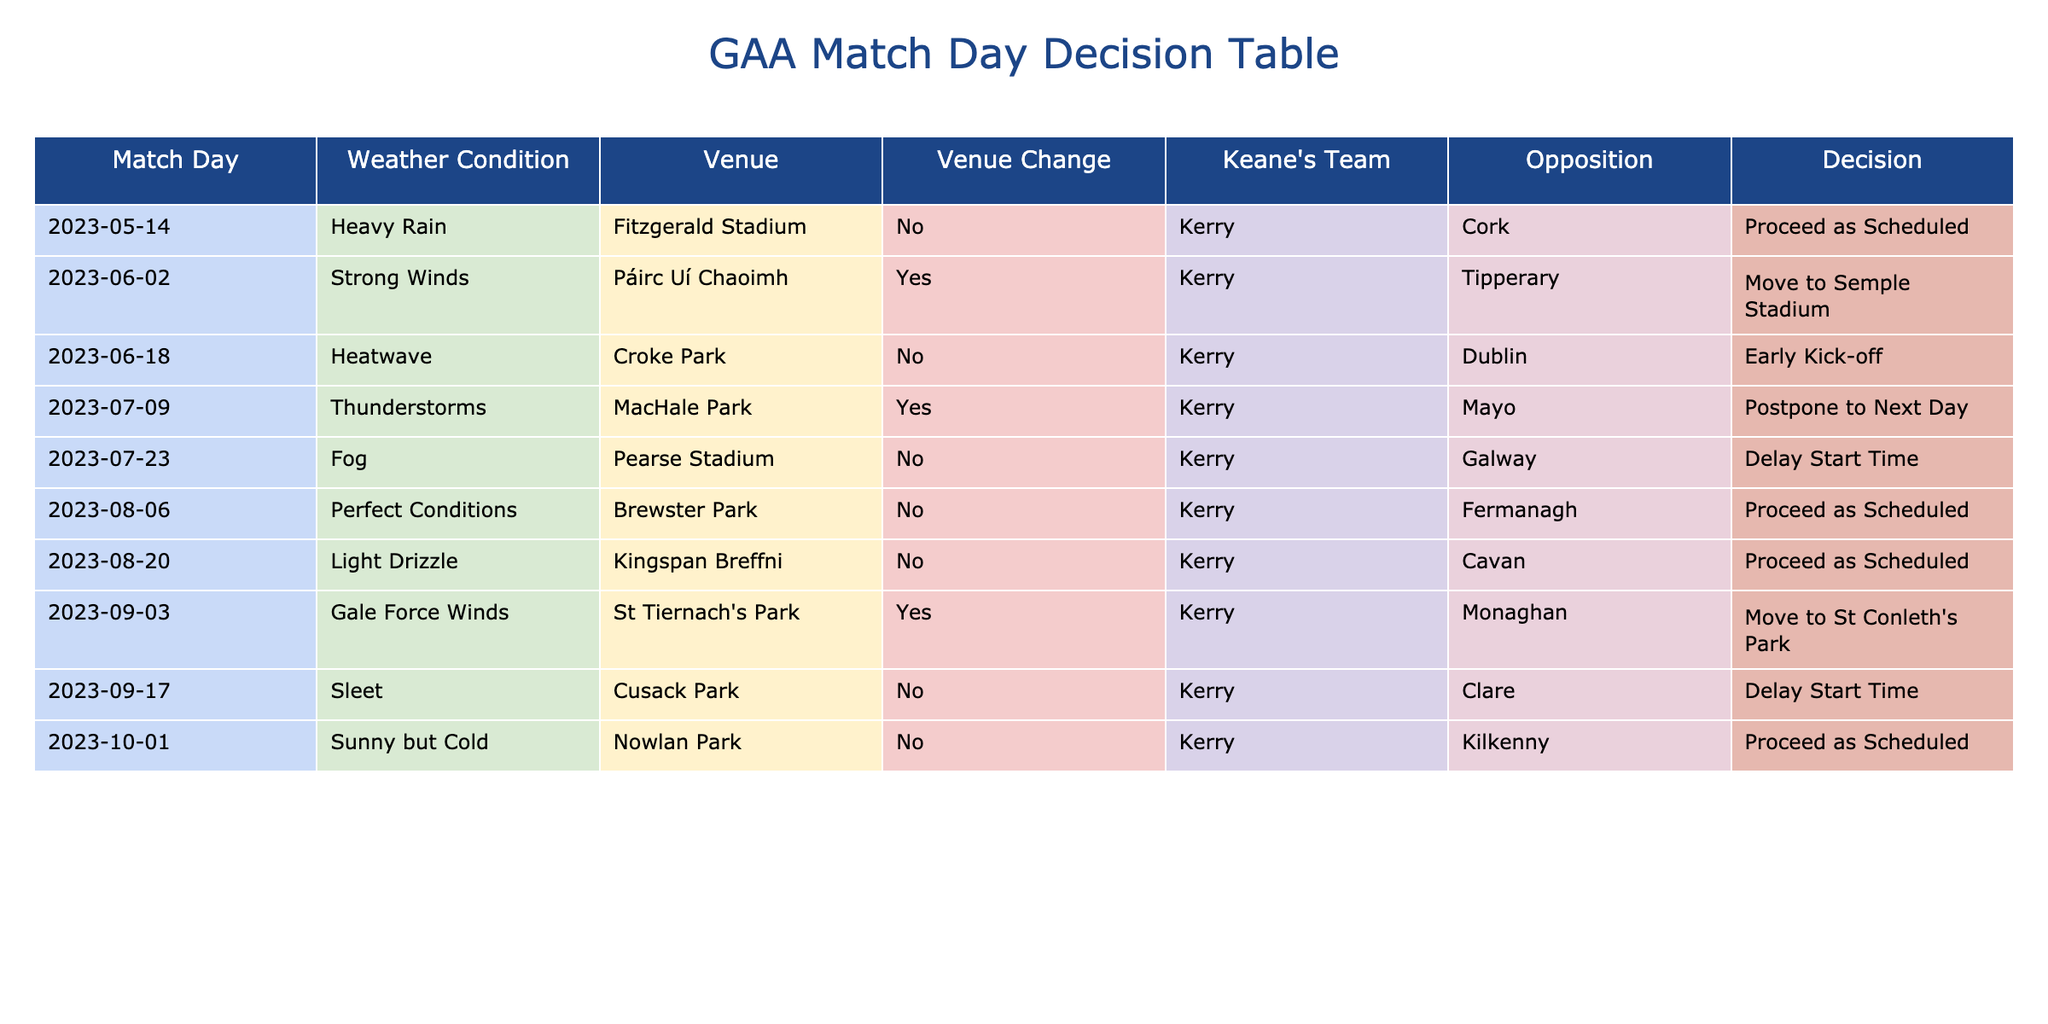What was the weather condition during the match on June 2, 2023? According to the table, on June 2, 2023, the weather condition was "Strong Winds."
Answer: Strong Winds Which match was postponed to the next day? The match scheduled for July 9, 2023, was postponed due to "Thunderstorms."
Answer: July 9, 2023 How many matches were played under perfect conditions? There was one match listed with "Perfect Conditions," which took place on August 6, 2023.
Answer: 1 Was there a venue change for the match against Tipperary? Yes, for the match against Tipperary on June 2, 2023, the venue was moved to Semple Stadium.
Answer: Yes What is the total number of matches scheduled at Fitzgerald Stadium? There is one match scheduled at Fitzgerald Stadium on May 14, 2023. Therefore, the total number is 1.
Answer: 1 On how many occasions was the match delayed? The matches were delayed in two instances: on July 23, 2023, and September 17, 2023, so the total is 2.
Answer: 2 Was there a match with a delay start time and no venue change? Yes, the match on September 17, 2023, had a delay start time and did not involve a venue change.
Answer: Yes What is the average weather condition for matches that had a venue change? The matches with venue changes occurred on June 2, July 9, and September 3, with weather conditions of "Strong Winds," "Thunderstorms," and "Gale Force Winds," respectively. There are three conditions; to summarize: they all indicate challenging weather. Therefore, the average sentiment reflects unfavorable weather overall.
Answer: Challenging How many matches were played in Croke Park? There is one match scheduled at Croke Park on June 18, 2023.
Answer: 1 